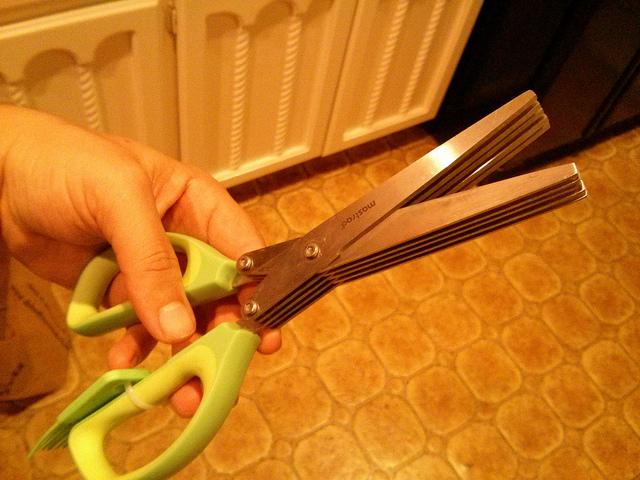What is the floor covered with?
Concise answer only. Linoleum. What color is the handle?
Concise answer only. Green. What are these scissors used for?
Quick response, please. Cutting. 